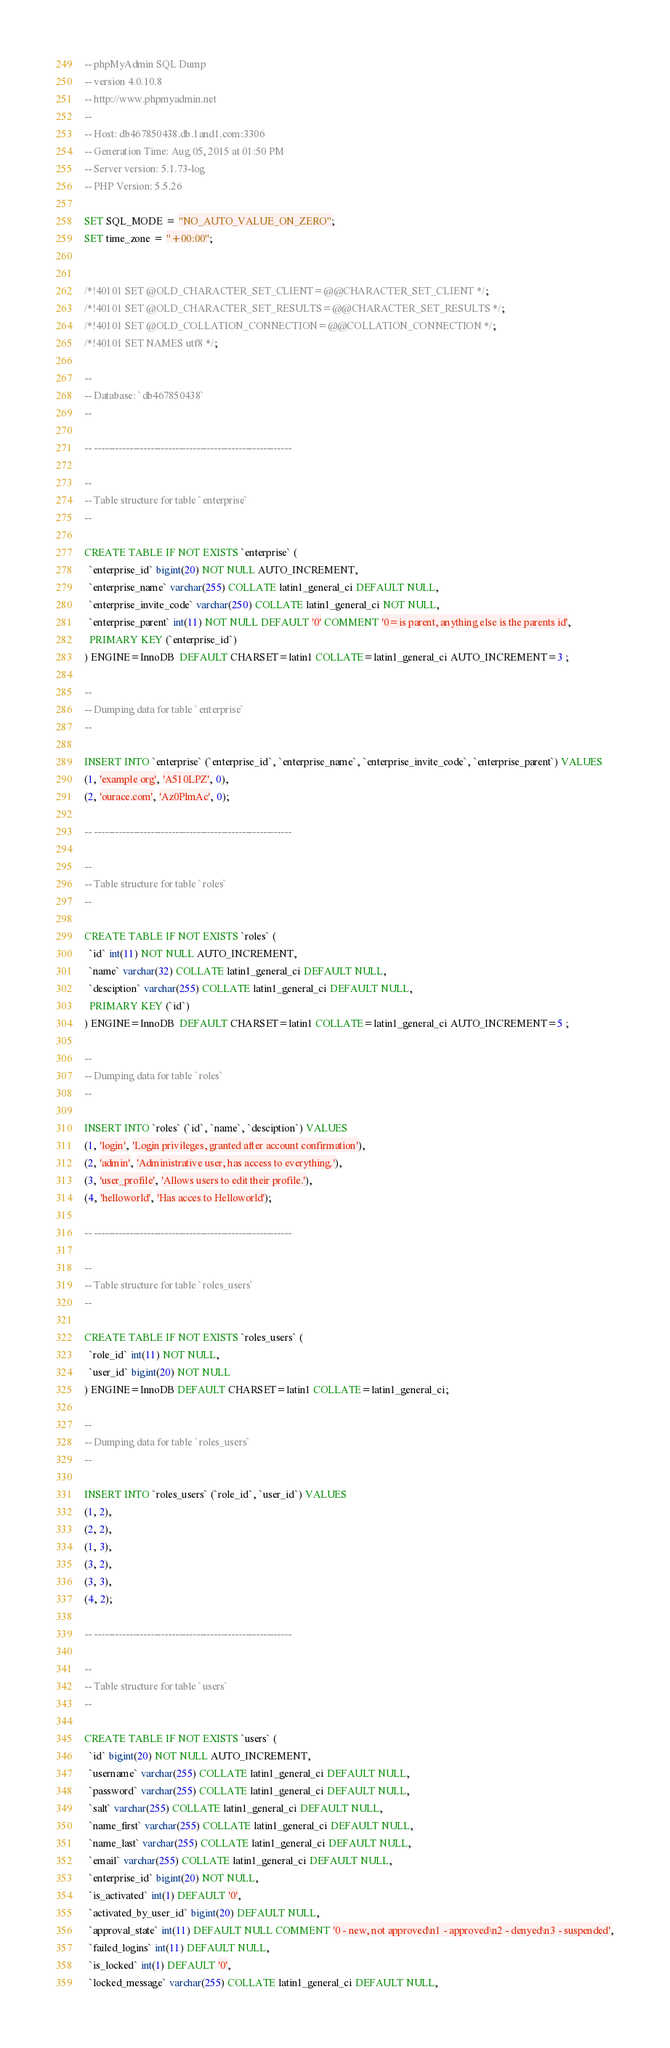Convert code to text. <code><loc_0><loc_0><loc_500><loc_500><_SQL_>-- phpMyAdmin SQL Dump
-- version 4.0.10.8
-- http://www.phpmyadmin.net
--
-- Host: db467850438.db.1and1.com:3306
-- Generation Time: Aug 05, 2015 at 01:50 PM
-- Server version: 5.1.73-log
-- PHP Version: 5.5.26

SET SQL_MODE = "NO_AUTO_VALUE_ON_ZERO";
SET time_zone = "+00:00";


/*!40101 SET @OLD_CHARACTER_SET_CLIENT=@@CHARACTER_SET_CLIENT */;
/*!40101 SET @OLD_CHARACTER_SET_RESULTS=@@CHARACTER_SET_RESULTS */;
/*!40101 SET @OLD_COLLATION_CONNECTION=@@COLLATION_CONNECTION */;
/*!40101 SET NAMES utf8 */;

--
-- Database: `db467850438`
--

-- --------------------------------------------------------

--
-- Table structure for table `enterprise`
--

CREATE TABLE IF NOT EXISTS `enterprise` (
  `enterprise_id` bigint(20) NOT NULL AUTO_INCREMENT,
  `enterprise_name` varchar(255) COLLATE latin1_general_ci DEFAULT NULL,
  `enterprise_invite_code` varchar(250) COLLATE latin1_general_ci NOT NULL,
  `enterprise_parent` int(11) NOT NULL DEFAULT '0' COMMENT '0=is parent, anything else is the parents id',
  PRIMARY KEY (`enterprise_id`)
) ENGINE=InnoDB  DEFAULT CHARSET=latin1 COLLATE=latin1_general_ci AUTO_INCREMENT=3 ;

--
-- Dumping data for table `enterprise`
--

INSERT INTO `enterprise` (`enterprise_id`, `enterprise_name`, `enterprise_invite_code`, `enterprise_parent`) VALUES
(1, 'example org', 'A510LPZ', 0),
(2, 'ourace.com', 'Az0PlmAc', 0);

-- --------------------------------------------------------

--
-- Table structure for table `roles`
--

CREATE TABLE IF NOT EXISTS `roles` (
  `id` int(11) NOT NULL AUTO_INCREMENT,
  `name` varchar(32) COLLATE latin1_general_ci DEFAULT NULL,
  `desciption` varchar(255) COLLATE latin1_general_ci DEFAULT NULL,
  PRIMARY KEY (`id`)
) ENGINE=InnoDB  DEFAULT CHARSET=latin1 COLLATE=latin1_general_ci AUTO_INCREMENT=5 ;

--
-- Dumping data for table `roles`
--

INSERT INTO `roles` (`id`, `name`, `desciption`) VALUES
(1, 'login', 'Login privileges, granted after account confirmation'),
(2, 'admin', 'Administrative user, has access to everything.'),
(3, 'user_profile', 'Allows users to edit their profile.'),
(4, 'helloworld', 'Has acces to Helloworld');

-- --------------------------------------------------------

--
-- Table structure for table `roles_users`
--

CREATE TABLE IF NOT EXISTS `roles_users` (
  `role_id` int(11) NOT NULL,
  `user_id` bigint(20) NOT NULL
) ENGINE=InnoDB DEFAULT CHARSET=latin1 COLLATE=latin1_general_ci;

--
-- Dumping data for table `roles_users`
--

INSERT INTO `roles_users` (`role_id`, `user_id`) VALUES
(1, 2),
(2, 2),
(1, 3),
(3, 2),
(3, 3),
(4, 2);

-- --------------------------------------------------------

--
-- Table structure for table `users`
--

CREATE TABLE IF NOT EXISTS `users` (
  `id` bigint(20) NOT NULL AUTO_INCREMENT,
  `username` varchar(255) COLLATE latin1_general_ci DEFAULT NULL,
  `password` varchar(255) COLLATE latin1_general_ci DEFAULT NULL,
  `salt` varchar(255) COLLATE latin1_general_ci DEFAULT NULL,
  `name_first` varchar(255) COLLATE latin1_general_ci DEFAULT NULL,
  `name_last` varchar(255) COLLATE latin1_general_ci DEFAULT NULL,
  `email` varchar(255) COLLATE latin1_general_ci DEFAULT NULL,
  `enterprise_id` bigint(20) NOT NULL,
  `is_activated` int(1) DEFAULT '0',
  `activated_by_user_id` bigint(20) DEFAULT NULL,
  `approval_state` int(11) DEFAULT NULL COMMENT '0 - new, not approved\n1 - approved\n2 - denyed\n3 - suspended',
  `failed_logins` int(11) DEFAULT NULL,
  `is_locked` int(1) DEFAULT '0',
  `locked_message` varchar(255) COLLATE latin1_general_ci DEFAULT NULL,</code> 